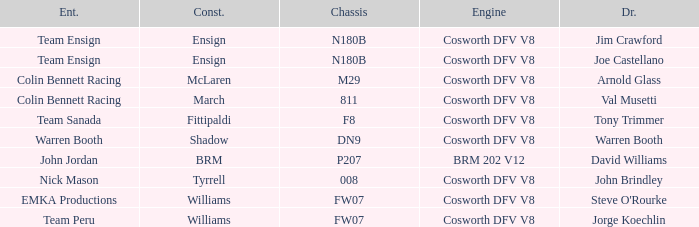What chassis does the shadow built car use? DN9. 